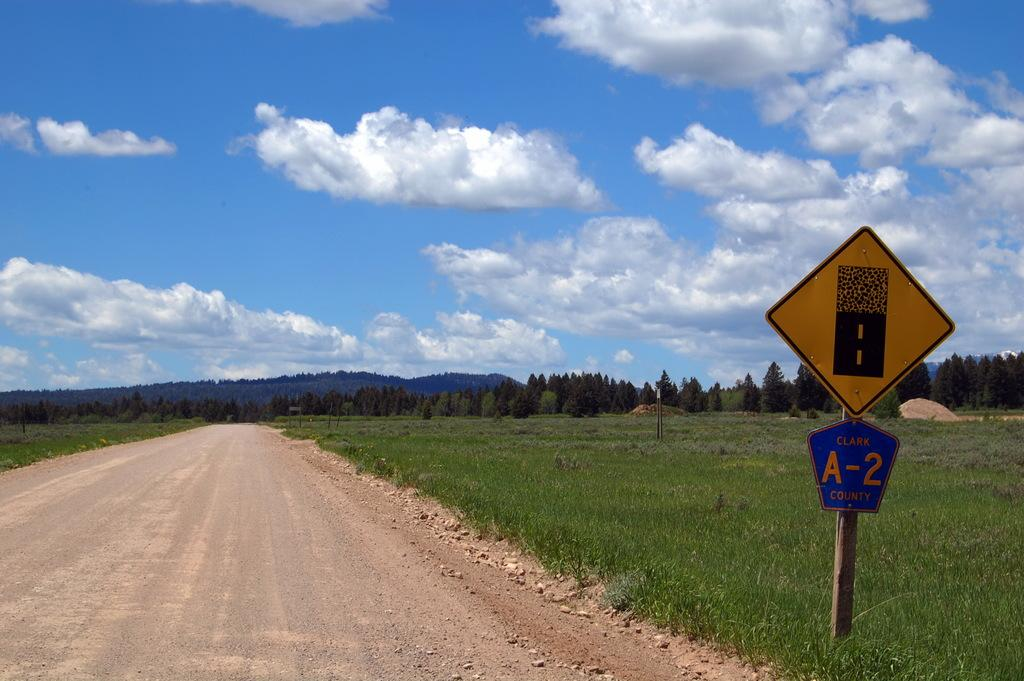Provide a one-sentence caption for the provided image. Gravel to paved road signs mark this A-2 county road. 